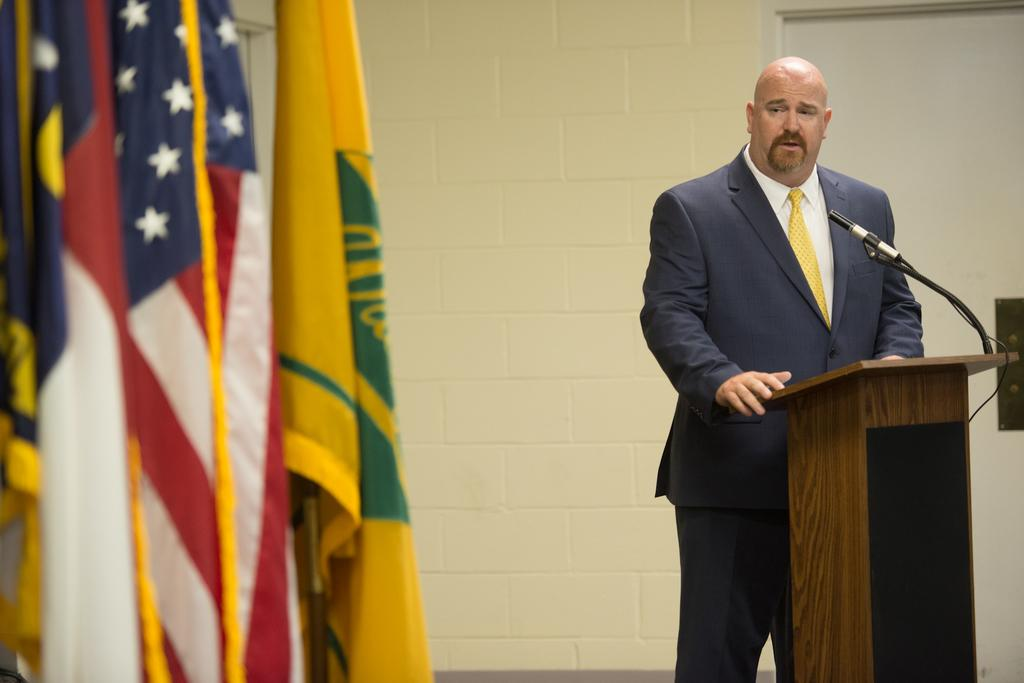What is the person in the image doing? The person is standing in front of the podium. What is on the podium? There is a mic on the podium. What can be seen in the background of the image? Flags are visible in the image. What architectural features can be seen in the image? There is a door and a wall in the image. What type of desk is the woman sitting behind in the image? There is no woman present in the image, and there is no desk visible. 